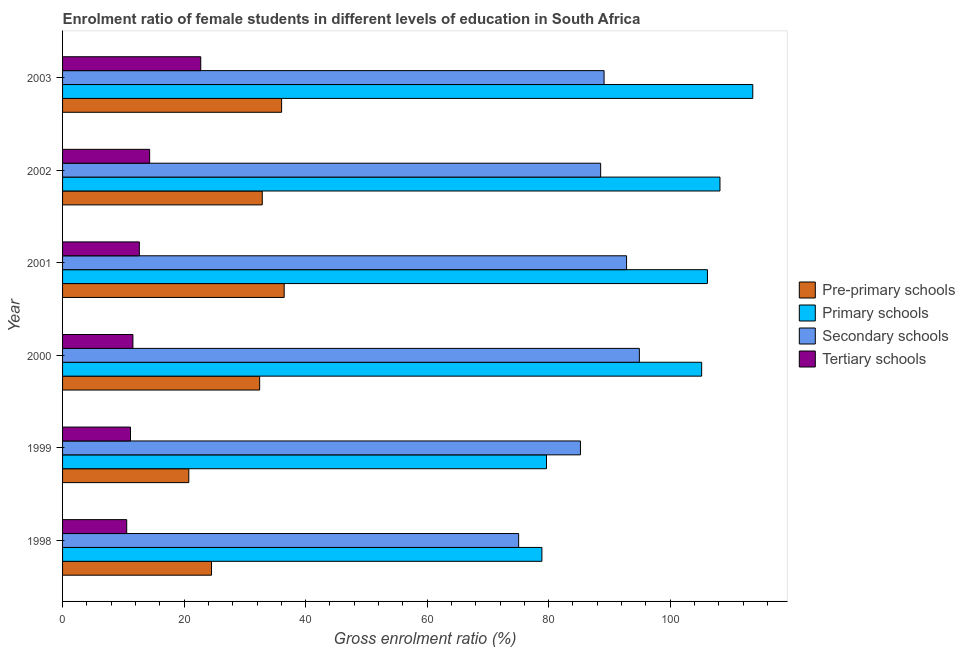How many groups of bars are there?
Your response must be concise. 6. Are the number of bars on each tick of the Y-axis equal?
Offer a very short reply. Yes. How many bars are there on the 5th tick from the top?
Keep it short and to the point. 4. What is the gross enrolment ratio(male) in tertiary schools in 2000?
Your answer should be very brief. 11.58. Across all years, what is the maximum gross enrolment ratio(male) in pre-primary schools?
Make the answer very short. 36.47. Across all years, what is the minimum gross enrolment ratio(male) in primary schools?
Offer a terse response. 78.89. In which year was the gross enrolment ratio(male) in tertiary schools maximum?
Ensure brevity in your answer.  2003. What is the total gross enrolment ratio(male) in secondary schools in the graph?
Your response must be concise. 525.71. What is the difference between the gross enrolment ratio(male) in secondary schools in 1998 and that in 2000?
Your response must be concise. -19.87. What is the difference between the gross enrolment ratio(male) in primary schools in 2000 and the gross enrolment ratio(male) in tertiary schools in 2001?
Your response must be concise. 92.54. What is the average gross enrolment ratio(male) in primary schools per year?
Provide a short and direct response. 98.6. In the year 2003, what is the difference between the gross enrolment ratio(male) in secondary schools and gross enrolment ratio(male) in tertiary schools?
Your response must be concise. 66.38. In how many years, is the gross enrolment ratio(male) in pre-primary schools greater than 4 %?
Provide a short and direct response. 6. Is the gross enrolment ratio(male) in pre-primary schools in 1998 less than that in 2000?
Provide a short and direct response. Yes. What is the difference between the highest and the second highest gross enrolment ratio(male) in tertiary schools?
Ensure brevity in your answer.  8.41. What is the difference between the highest and the lowest gross enrolment ratio(male) in tertiary schools?
Your response must be concise. 12.18. Is it the case that in every year, the sum of the gross enrolment ratio(male) in pre-primary schools and gross enrolment ratio(male) in secondary schools is greater than the sum of gross enrolment ratio(male) in tertiary schools and gross enrolment ratio(male) in primary schools?
Ensure brevity in your answer.  No. What does the 4th bar from the top in 2003 represents?
Your answer should be very brief. Pre-primary schools. What does the 1st bar from the bottom in 2002 represents?
Make the answer very short. Pre-primary schools. Is it the case that in every year, the sum of the gross enrolment ratio(male) in pre-primary schools and gross enrolment ratio(male) in primary schools is greater than the gross enrolment ratio(male) in secondary schools?
Keep it short and to the point. Yes. How many bars are there?
Ensure brevity in your answer.  24. Are all the bars in the graph horizontal?
Your response must be concise. Yes. How many years are there in the graph?
Offer a terse response. 6. What is the difference between two consecutive major ticks on the X-axis?
Keep it short and to the point. 20. Are the values on the major ticks of X-axis written in scientific E-notation?
Provide a short and direct response. No. How many legend labels are there?
Make the answer very short. 4. How are the legend labels stacked?
Offer a very short reply. Vertical. What is the title of the graph?
Offer a terse response. Enrolment ratio of female students in different levels of education in South Africa. Does "Macroeconomic management" appear as one of the legend labels in the graph?
Make the answer very short. No. What is the label or title of the X-axis?
Ensure brevity in your answer.  Gross enrolment ratio (%). What is the label or title of the Y-axis?
Make the answer very short. Year. What is the Gross enrolment ratio (%) in Pre-primary schools in 1998?
Ensure brevity in your answer.  24.51. What is the Gross enrolment ratio (%) of Primary schools in 1998?
Your answer should be very brief. 78.89. What is the Gross enrolment ratio (%) in Secondary schools in 1998?
Offer a very short reply. 75.06. What is the Gross enrolment ratio (%) in Tertiary schools in 1998?
Make the answer very short. 10.56. What is the Gross enrolment ratio (%) in Pre-primary schools in 1999?
Make the answer very short. 20.78. What is the Gross enrolment ratio (%) in Primary schools in 1999?
Ensure brevity in your answer.  79.64. What is the Gross enrolment ratio (%) of Secondary schools in 1999?
Your answer should be compact. 85.23. What is the Gross enrolment ratio (%) of Tertiary schools in 1999?
Your answer should be compact. 11.18. What is the Gross enrolment ratio (%) in Pre-primary schools in 2000?
Ensure brevity in your answer.  32.44. What is the Gross enrolment ratio (%) in Primary schools in 2000?
Your response must be concise. 105.18. What is the Gross enrolment ratio (%) in Secondary schools in 2000?
Your response must be concise. 94.93. What is the Gross enrolment ratio (%) in Tertiary schools in 2000?
Ensure brevity in your answer.  11.58. What is the Gross enrolment ratio (%) in Pre-primary schools in 2001?
Keep it short and to the point. 36.47. What is the Gross enrolment ratio (%) in Primary schools in 2001?
Your answer should be very brief. 106.13. What is the Gross enrolment ratio (%) in Secondary schools in 2001?
Ensure brevity in your answer.  92.82. What is the Gross enrolment ratio (%) of Tertiary schools in 2001?
Your answer should be very brief. 12.64. What is the Gross enrolment ratio (%) of Pre-primary schools in 2002?
Your response must be concise. 32.87. What is the Gross enrolment ratio (%) of Primary schools in 2002?
Provide a short and direct response. 108.19. What is the Gross enrolment ratio (%) in Secondary schools in 2002?
Your answer should be very brief. 88.56. What is the Gross enrolment ratio (%) of Tertiary schools in 2002?
Ensure brevity in your answer.  14.33. What is the Gross enrolment ratio (%) in Pre-primary schools in 2003?
Offer a terse response. 36.05. What is the Gross enrolment ratio (%) in Primary schools in 2003?
Offer a terse response. 113.59. What is the Gross enrolment ratio (%) of Secondary schools in 2003?
Provide a short and direct response. 89.12. What is the Gross enrolment ratio (%) in Tertiary schools in 2003?
Give a very brief answer. 22.74. Across all years, what is the maximum Gross enrolment ratio (%) of Pre-primary schools?
Provide a short and direct response. 36.47. Across all years, what is the maximum Gross enrolment ratio (%) of Primary schools?
Give a very brief answer. 113.59. Across all years, what is the maximum Gross enrolment ratio (%) in Secondary schools?
Your answer should be compact. 94.93. Across all years, what is the maximum Gross enrolment ratio (%) of Tertiary schools?
Provide a short and direct response. 22.74. Across all years, what is the minimum Gross enrolment ratio (%) in Pre-primary schools?
Provide a short and direct response. 20.78. Across all years, what is the minimum Gross enrolment ratio (%) of Primary schools?
Provide a succinct answer. 78.89. Across all years, what is the minimum Gross enrolment ratio (%) in Secondary schools?
Provide a short and direct response. 75.06. Across all years, what is the minimum Gross enrolment ratio (%) of Tertiary schools?
Keep it short and to the point. 10.56. What is the total Gross enrolment ratio (%) in Pre-primary schools in the graph?
Offer a terse response. 183.11. What is the total Gross enrolment ratio (%) of Primary schools in the graph?
Offer a very short reply. 591.62. What is the total Gross enrolment ratio (%) of Secondary schools in the graph?
Ensure brevity in your answer.  525.71. What is the total Gross enrolment ratio (%) of Tertiary schools in the graph?
Your answer should be very brief. 83.02. What is the difference between the Gross enrolment ratio (%) in Pre-primary schools in 1998 and that in 1999?
Keep it short and to the point. 3.74. What is the difference between the Gross enrolment ratio (%) of Primary schools in 1998 and that in 1999?
Provide a short and direct response. -0.76. What is the difference between the Gross enrolment ratio (%) in Secondary schools in 1998 and that in 1999?
Your answer should be compact. -10.17. What is the difference between the Gross enrolment ratio (%) of Tertiary schools in 1998 and that in 1999?
Provide a succinct answer. -0.62. What is the difference between the Gross enrolment ratio (%) of Pre-primary schools in 1998 and that in 2000?
Give a very brief answer. -7.92. What is the difference between the Gross enrolment ratio (%) of Primary schools in 1998 and that in 2000?
Make the answer very short. -26.29. What is the difference between the Gross enrolment ratio (%) in Secondary schools in 1998 and that in 2000?
Offer a terse response. -19.87. What is the difference between the Gross enrolment ratio (%) in Tertiary schools in 1998 and that in 2000?
Offer a very short reply. -1.02. What is the difference between the Gross enrolment ratio (%) of Pre-primary schools in 1998 and that in 2001?
Your answer should be very brief. -11.96. What is the difference between the Gross enrolment ratio (%) in Primary schools in 1998 and that in 2001?
Provide a short and direct response. -27.24. What is the difference between the Gross enrolment ratio (%) in Secondary schools in 1998 and that in 2001?
Provide a short and direct response. -17.76. What is the difference between the Gross enrolment ratio (%) in Tertiary schools in 1998 and that in 2001?
Give a very brief answer. -2.08. What is the difference between the Gross enrolment ratio (%) of Pre-primary schools in 1998 and that in 2002?
Your answer should be very brief. -8.35. What is the difference between the Gross enrolment ratio (%) in Primary schools in 1998 and that in 2002?
Ensure brevity in your answer.  -29.31. What is the difference between the Gross enrolment ratio (%) in Secondary schools in 1998 and that in 2002?
Give a very brief answer. -13.5. What is the difference between the Gross enrolment ratio (%) in Tertiary schools in 1998 and that in 2002?
Your response must be concise. -3.77. What is the difference between the Gross enrolment ratio (%) of Pre-primary schools in 1998 and that in 2003?
Offer a terse response. -11.53. What is the difference between the Gross enrolment ratio (%) of Primary schools in 1998 and that in 2003?
Your response must be concise. -34.7. What is the difference between the Gross enrolment ratio (%) in Secondary schools in 1998 and that in 2003?
Your answer should be very brief. -14.06. What is the difference between the Gross enrolment ratio (%) in Tertiary schools in 1998 and that in 2003?
Your response must be concise. -12.18. What is the difference between the Gross enrolment ratio (%) of Pre-primary schools in 1999 and that in 2000?
Your answer should be compact. -11.66. What is the difference between the Gross enrolment ratio (%) in Primary schools in 1999 and that in 2000?
Offer a very short reply. -25.53. What is the difference between the Gross enrolment ratio (%) of Secondary schools in 1999 and that in 2000?
Offer a very short reply. -9.69. What is the difference between the Gross enrolment ratio (%) of Tertiary schools in 1999 and that in 2000?
Your response must be concise. -0.4. What is the difference between the Gross enrolment ratio (%) in Pre-primary schools in 1999 and that in 2001?
Give a very brief answer. -15.7. What is the difference between the Gross enrolment ratio (%) of Primary schools in 1999 and that in 2001?
Provide a short and direct response. -26.49. What is the difference between the Gross enrolment ratio (%) of Secondary schools in 1999 and that in 2001?
Provide a succinct answer. -7.59. What is the difference between the Gross enrolment ratio (%) in Tertiary schools in 1999 and that in 2001?
Your answer should be compact. -1.46. What is the difference between the Gross enrolment ratio (%) in Pre-primary schools in 1999 and that in 2002?
Ensure brevity in your answer.  -12.09. What is the difference between the Gross enrolment ratio (%) of Primary schools in 1999 and that in 2002?
Offer a terse response. -28.55. What is the difference between the Gross enrolment ratio (%) in Secondary schools in 1999 and that in 2002?
Your response must be concise. -3.32. What is the difference between the Gross enrolment ratio (%) in Tertiary schools in 1999 and that in 2002?
Your response must be concise. -3.15. What is the difference between the Gross enrolment ratio (%) of Pre-primary schools in 1999 and that in 2003?
Your answer should be very brief. -15.27. What is the difference between the Gross enrolment ratio (%) of Primary schools in 1999 and that in 2003?
Your answer should be very brief. -33.95. What is the difference between the Gross enrolment ratio (%) in Secondary schools in 1999 and that in 2003?
Provide a short and direct response. -3.89. What is the difference between the Gross enrolment ratio (%) of Tertiary schools in 1999 and that in 2003?
Provide a succinct answer. -11.56. What is the difference between the Gross enrolment ratio (%) in Pre-primary schools in 2000 and that in 2001?
Ensure brevity in your answer.  -4.03. What is the difference between the Gross enrolment ratio (%) in Primary schools in 2000 and that in 2001?
Ensure brevity in your answer.  -0.95. What is the difference between the Gross enrolment ratio (%) in Secondary schools in 2000 and that in 2001?
Provide a short and direct response. 2.1. What is the difference between the Gross enrolment ratio (%) of Tertiary schools in 2000 and that in 2001?
Ensure brevity in your answer.  -1.06. What is the difference between the Gross enrolment ratio (%) in Pre-primary schools in 2000 and that in 2002?
Your response must be concise. -0.43. What is the difference between the Gross enrolment ratio (%) in Primary schools in 2000 and that in 2002?
Provide a succinct answer. -3.02. What is the difference between the Gross enrolment ratio (%) in Secondary schools in 2000 and that in 2002?
Offer a terse response. 6.37. What is the difference between the Gross enrolment ratio (%) of Tertiary schools in 2000 and that in 2002?
Your answer should be very brief. -2.75. What is the difference between the Gross enrolment ratio (%) in Pre-primary schools in 2000 and that in 2003?
Your response must be concise. -3.61. What is the difference between the Gross enrolment ratio (%) in Primary schools in 2000 and that in 2003?
Keep it short and to the point. -8.41. What is the difference between the Gross enrolment ratio (%) in Secondary schools in 2000 and that in 2003?
Provide a short and direct response. 5.81. What is the difference between the Gross enrolment ratio (%) in Tertiary schools in 2000 and that in 2003?
Keep it short and to the point. -11.16. What is the difference between the Gross enrolment ratio (%) of Pre-primary schools in 2001 and that in 2002?
Give a very brief answer. 3.61. What is the difference between the Gross enrolment ratio (%) of Primary schools in 2001 and that in 2002?
Provide a succinct answer. -2.06. What is the difference between the Gross enrolment ratio (%) of Secondary schools in 2001 and that in 2002?
Your answer should be compact. 4.27. What is the difference between the Gross enrolment ratio (%) of Tertiary schools in 2001 and that in 2002?
Give a very brief answer. -1.69. What is the difference between the Gross enrolment ratio (%) of Pre-primary schools in 2001 and that in 2003?
Offer a very short reply. 0.42. What is the difference between the Gross enrolment ratio (%) of Primary schools in 2001 and that in 2003?
Offer a very short reply. -7.46. What is the difference between the Gross enrolment ratio (%) of Secondary schools in 2001 and that in 2003?
Offer a terse response. 3.7. What is the difference between the Gross enrolment ratio (%) in Tertiary schools in 2001 and that in 2003?
Provide a short and direct response. -10.11. What is the difference between the Gross enrolment ratio (%) of Pre-primary schools in 2002 and that in 2003?
Ensure brevity in your answer.  -3.18. What is the difference between the Gross enrolment ratio (%) in Primary schools in 2002 and that in 2003?
Your response must be concise. -5.4. What is the difference between the Gross enrolment ratio (%) in Secondary schools in 2002 and that in 2003?
Ensure brevity in your answer.  -0.56. What is the difference between the Gross enrolment ratio (%) of Tertiary schools in 2002 and that in 2003?
Your answer should be very brief. -8.41. What is the difference between the Gross enrolment ratio (%) of Pre-primary schools in 1998 and the Gross enrolment ratio (%) of Primary schools in 1999?
Make the answer very short. -55.13. What is the difference between the Gross enrolment ratio (%) in Pre-primary schools in 1998 and the Gross enrolment ratio (%) in Secondary schools in 1999?
Ensure brevity in your answer.  -60.72. What is the difference between the Gross enrolment ratio (%) in Pre-primary schools in 1998 and the Gross enrolment ratio (%) in Tertiary schools in 1999?
Offer a very short reply. 13.33. What is the difference between the Gross enrolment ratio (%) of Primary schools in 1998 and the Gross enrolment ratio (%) of Secondary schools in 1999?
Provide a succinct answer. -6.34. What is the difference between the Gross enrolment ratio (%) in Primary schools in 1998 and the Gross enrolment ratio (%) in Tertiary schools in 1999?
Your answer should be compact. 67.71. What is the difference between the Gross enrolment ratio (%) of Secondary schools in 1998 and the Gross enrolment ratio (%) of Tertiary schools in 1999?
Offer a terse response. 63.88. What is the difference between the Gross enrolment ratio (%) in Pre-primary schools in 1998 and the Gross enrolment ratio (%) in Primary schools in 2000?
Ensure brevity in your answer.  -80.66. What is the difference between the Gross enrolment ratio (%) of Pre-primary schools in 1998 and the Gross enrolment ratio (%) of Secondary schools in 2000?
Your answer should be very brief. -70.41. What is the difference between the Gross enrolment ratio (%) of Pre-primary schools in 1998 and the Gross enrolment ratio (%) of Tertiary schools in 2000?
Provide a succinct answer. 12.94. What is the difference between the Gross enrolment ratio (%) in Primary schools in 1998 and the Gross enrolment ratio (%) in Secondary schools in 2000?
Keep it short and to the point. -16.04. What is the difference between the Gross enrolment ratio (%) in Primary schools in 1998 and the Gross enrolment ratio (%) in Tertiary schools in 2000?
Offer a very short reply. 67.31. What is the difference between the Gross enrolment ratio (%) of Secondary schools in 1998 and the Gross enrolment ratio (%) of Tertiary schools in 2000?
Your answer should be very brief. 63.48. What is the difference between the Gross enrolment ratio (%) of Pre-primary schools in 1998 and the Gross enrolment ratio (%) of Primary schools in 2001?
Provide a short and direct response. -81.62. What is the difference between the Gross enrolment ratio (%) of Pre-primary schools in 1998 and the Gross enrolment ratio (%) of Secondary schools in 2001?
Provide a short and direct response. -68.31. What is the difference between the Gross enrolment ratio (%) in Pre-primary schools in 1998 and the Gross enrolment ratio (%) in Tertiary schools in 2001?
Your response must be concise. 11.88. What is the difference between the Gross enrolment ratio (%) of Primary schools in 1998 and the Gross enrolment ratio (%) of Secondary schools in 2001?
Your answer should be compact. -13.93. What is the difference between the Gross enrolment ratio (%) in Primary schools in 1998 and the Gross enrolment ratio (%) in Tertiary schools in 2001?
Keep it short and to the point. 66.25. What is the difference between the Gross enrolment ratio (%) of Secondary schools in 1998 and the Gross enrolment ratio (%) of Tertiary schools in 2001?
Your response must be concise. 62.42. What is the difference between the Gross enrolment ratio (%) in Pre-primary schools in 1998 and the Gross enrolment ratio (%) in Primary schools in 2002?
Make the answer very short. -83.68. What is the difference between the Gross enrolment ratio (%) in Pre-primary schools in 1998 and the Gross enrolment ratio (%) in Secondary schools in 2002?
Make the answer very short. -64.04. What is the difference between the Gross enrolment ratio (%) in Pre-primary schools in 1998 and the Gross enrolment ratio (%) in Tertiary schools in 2002?
Ensure brevity in your answer.  10.18. What is the difference between the Gross enrolment ratio (%) of Primary schools in 1998 and the Gross enrolment ratio (%) of Secondary schools in 2002?
Your answer should be compact. -9.67. What is the difference between the Gross enrolment ratio (%) in Primary schools in 1998 and the Gross enrolment ratio (%) in Tertiary schools in 2002?
Make the answer very short. 64.56. What is the difference between the Gross enrolment ratio (%) in Secondary schools in 1998 and the Gross enrolment ratio (%) in Tertiary schools in 2002?
Provide a short and direct response. 60.73. What is the difference between the Gross enrolment ratio (%) of Pre-primary schools in 1998 and the Gross enrolment ratio (%) of Primary schools in 2003?
Keep it short and to the point. -89.08. What is the difference between the Gross enrolment ratio (%) in Pre-primary schools in 1998 and the Gross enrolment ratio (%) in Secondary schools in 2003?
Ensure brevity in your answer.  -64.61. What is the difference between the Gross enrolment ratio (%) in Pre-primary schools in 1998 and the Gross enrolment ratio (%) in Tertiary schools in 2003?
Give a very brief answer. 1.77. What is the difference between the Gross enrolment ratio (%) of Primary schools in 1998 and the Gross enrolment ratio (%) of Secondary schools in 2003?
Ensure brevity in your answer.  -10.23. What is the difference between the Gross enrolment ratio (%) in Primary schools in 1998 and the Gross enrolment ratio (%) in Tertiary schools in 2003?
Provide a short and direct response. 56.15. What is the difference between the Gross enrolment ratio (%) of Secondary schools in 1998 and the Gross enrolment ratio (%) of Tertiary schools in 2003?
Provide a short and direct response. 52.31. What is the difference between the Gross enrolment ratio (%) of Pre-primary schools in 1999 and the Gross enrolment ratio (%) of Primary schools in 2000?
Offer a very short reply. -84.4. What is the difference between the Gross enrolment ratio (%) in Pre-primary schools in 1999 and the Gross enrolment ratio (%) in Secondary schools in 2000?
Provide a short and direct response. -74.15. What is the difference between the Gross enrolment ratio (%) in Pre-primary schools in 1999 and the Gross enrolment ratio (%) in Tertiary schools in 2000?
Provide a succinct answer. 9.2. What is the difference between the Gross enrolment ratio (%) in Primary schools in 1999 and the Gross enrolment ratio (%) in Secondary schools in 2000?
Make the answer very short. -15.28. What is the difference between the Gross enrolment ratio (%) in Primary schools in 1999 and the Gross enrolment ratio (%) in Tertiary schools in 2000?
Your answer should be very brief. 68.07. What is the difference between the Gross enrolment ratio (%) in Secondary schools in 1999 and the Gross enrolment ratio (%) in Tertiary schools in 2000?
Offer a terse response. 73.65. What is the difference between the Gross enrolment ratio (%) of Pre-primary schools in 1999 and the Gross enrolment ratio (%) of Primary schools in 2001?
Ensure brevity in your answer.  -85.35. What is the difference between the Gross enrolment ratio (%) in Pre-primary schools in 1999 and the Gross enrolment ratio (%) in Secondary schools in 2001?
Provide a short and direct response. -72.05. What is the difference between the Gross enrolment ratio (%) in Pre-primary schools in 1999 and the Gross enrolment ratio (%) in Tertiary schools in 2001?
Your answer should be compact. 8.14. What is the difference between the Gross enrolment ratio (%) of Primary schools in 1999 and the Gross enrolment ratio (%) of Secondary schools in 2001?
Your response must be concise. -13.18. What is the difference between the Gross enrolment ratio (%) of Primary schools in 1999 and the Gross enrolment ratio (%) of Tertiary schools in 2001?
Keep it short and to the point. 67.01. What is the difference between the Gross enrolment ratio (%) of Secondary schools in 1999 and the Gross enrolment ratio (%) of Tertiary schools in 2001?
Ensure brevity in your answer.  72.6. What is the difference between the Gross enrolment ratio (%) of Pre-primary schools in 1999 and the Gross enrolment ratio (%) of Primary schools in 2002?
Keep it short and to the point. -87.42. What is the difference between the Gross enrolment ratio (%) of Pre-primary schools in 1999 and the Gross enrolment ratio (%) of Secondary schools in 2002?
Your response must be concise. -67.78. What is the difference between the Gross enrolment ratio (%) of Pre-primary schools in 1999 and the Gross enrolment ratio (%) of Tertiary schools in 2002?
Your answer should be very brief. 6.45. What is the difference between the Gross enrolment ratio (%) of Primary schools in 1999 and the Gross enrolment ratio (%) of Secondary schools in 2002?
Give a very brief answer. -8.91. What is the difference between the Gross enrolment ratio (%) of Primary schools in 1999 and the Gross enrolment ratio (%) of Tertiary schools in 2002?
Offer a very short reply. 65.31. What is the difference between the Gross enrolment ratio (%) in Secondary schools in 1999 and the Gross enrolment ratio (%) in Tertiary schools in 2002?
Make the answer very short. 70.9. What is the difference between the Gross enrolment ratio (%) in Pre-primary schools in 1999 and the Gross enrolment ratio (%) in Primary schools in 2003?
Keep it short and to the point. -92.82. What is the difference between the Gross enrolment ratio (%) in Pre-primary schools in 1999 and the Gross enrolment ratio (%) in Secondary schools in 2003?
Give a very brief answer. -68.34. What is the difference between the Gross enrolment ratio (%) in Pre-primary schools in 1999 and the Gross enrolment ratio (%) in Tertiary schools in 2003?
Offer a very short reply. -1.97. What is the difference between the Gross enrolment ratio (%) of Primary schools in 1999 and the Gross enrolment ratio (%) of Secondary schools in 2003?
Give a very brief answer. -9.48. What is the difference between the Gross enrolment ratio (%) of Primary schools in 1999 and the Gross enrolment ratio (%) of Tertiary schools in 2003?
Provide a short and direct response. 56.9. What is the difference between the Gross enrolment ratio (%) in Secondary schools in 1999 and the Gross enrolment ratio (%) in Tertiary schools in 2003?
Your answer should be very brief. 62.49. What is the difference between the Gross enrolment ratio (%) of Pre-primary schools in 2000 and the Gross enrolment ratio (%) of Primary schools in 2001?
Offer a terse response. -73.69. What is the difference between the Gross enrolment ratio (%) of Pre-primary schools in 2000 and the Gross enrolment ratio (%) of Secondary schools in 2001?
Offer a very short reply. -60.38. What is the difference between the Gross enrolment ratio (%) in Pre-primary schools in 2000 and the Gross enrolment ratio (%) in Tertiary schools in 2001?
Ensure brevity in your answer.  19.8. What is the difference between the Gross enrolment ratio (%) in Primary schools in 2000 and the Gross enrolment ratio (%) in Secondary schools in 2001?
Provide a short and direct response. 12.36. What is the difference between the Gross enrolment ratio (%) in Primary schools in 2000 and the Gross enrolment ratio (%) in Tertiary schools in 2001?
Offer a very short reply. 92.54. What is the difference between the Gross enrolment ratio (%) in Secondary schools in 2000 and the Gross enrolment ratio (%) in Tertiary schools in 2001?
Give a very brief answer. 82.29. What is the difference between the Gross enrolment ratio (%) of Pre-primary schools in 2000 and the Gross enrolment ratio (%) of Primary schools in 2002?
Offer a very short reply. -75.76. What is the difference between the Gross enrolment ratio (%) in Pre-primary schools in 2000 and the Gross enrolment ratio (%) in Secondary schools in 2002?
Your answer should be compact. -56.12. What is the difference between the Gross enrolment ratio (%) in Pre-primary schools in 2000 and the Gross enrolment ratio (%) in Tertiary schools in 2002?
Provide a succinct answer. 18.11. What is the difference between the Gross enrolment ratio (%) of Primary schools in 2000 and the Gross enrolment ratio (%) of Secondary schools in 2002?
Keep it short and to the point. 16.62. What is the difference between the Gross enrolment ratio (%) of Primary schools in 2000 and the Gross enrolment ratio (%) of Tertiary schools in 2002?
Offer a very short reply. 90.85. What is the difference between the Gross enrolment ratio (%) of Secondary schools in 2000 and the Gross enrolment ratio (%) of Tertiary schools in 2002?
Provide a short and direct response. 80.6. What is the difference between the Gross enrolment ratio (%) of Pre-primary schools in 2000 and the Gross enrolment ratio (%) of Primary schools in 2003?
Ensure brevity in your answer.  -81.15. What is the difference between the Gross enrolment ratio (%) of Pre-primary schools in 2000 and the Gross enrolment ratio (%) of Secondary schools in 2003?
Give a very brief answer. -56.68. What is the difference between the Gross enrolment ratio (%) of Pre-primary schools in 2000 and the Gross enrolment ratio (%) of Tertiary schools in 2003?
Offer a very short reply. 9.69. What is the difference between the Gross enrolment ratio (%) of Primary schools in 2000 and the Gross enrolment ratio (%) of Secondary schools in 2003?
Your response must be concise. 16.06. What is the difference between the Gross enrolment ratio (%) in Primary schools in 2000 and the Gross enrolment ratio (%) in Tertiary schools in 2003?
Your answer should be compact. 82.44. What is the difference between the Gross enrolment ratio (%) in Secondary schools in 2000 and the Gross enrolment ratio (%) in Tertiary schools in 2003?
Your response must be concise. 72.18. What is the difference between the Gross enrolment ratio (%) in Pre-primary schools in 2001 and the Gross enrolment ratio (%) in Primary schools in 2002?
Offer a terse response. -71.72. What is the difference between the Gross enrolment ratio (%) of Pre-primary schools in 2001 and the Gross enrolment ratio (%) of Secondary schools in 2002?
Ensure brevity in your answer.  -52.08. What is the difference between the Gross enrolment ratio (%) of Pre-primary schools in 2001 and the Gross enrolment ratio (%) of Tertiary schools in 2002?
Give a very brief answer. 22.14. What is the difference between the Gross enrolment ratio (%) in Primary schools in 2001 and the Gross enrolment ratio (%) in Secondary schools in 2002?
Provide a short and direct response. 17.57. What is the difference between the Gross enrolment ratio (%) in Primary schools in 2001 and the Gross enrolment ratio (%) in Tertiary schools in 2002?
Your response must be concise. 91.8. What is the difference between the Gross enrolment ratio (%) of Secondary schools in 2001 and the Gross enrolment ratio (%) of Tertiary schools in 2002?
Your response must be concise. 78.49. What is the difference between the Gross enrolment ratio (%) of Pre-primary schools in 2001 and the Gross enrolment ratio (%) of Primary schools in 2003?
Provide a short and direct response. -77.12. What is the difference between the Gross enrolment ratio (%) of Pre-primary schools in 2001 and the Gross enrolment ratio (%) of Secondary schools in 2003?
Provide a short and direct response. -52.65. What is the difference between the Gross enrolment ratio (%) in Pre-primary schools in 2001 and the Gross enrolment ratio (%) in Tertiary schools in 2003?
Your answer should be compact. 13.73. What is the difference between the Gross enrolment ratio (%) in Primary schools in 2001 and the Gross enrolment ratio (%) in Secondary schools in 2003?
Your answer should be very brief. 17.01. What is the difference between the Gross enrolment ratio (%) in Primary schools in 2001 and the Gross enrolment ratio (%) in Tertiary schools in 2003?
Your answer should be compact. 83.39. What is the difference between the Gross enrolment ratio (%) of Secondary schools in 2001 and the Gross enrolment ratio (%) of Tertiary schools in 2003?
Give a very brief answer. 70.08. What is the difference between the Gross enrolment ratio (%) of Pre-primary schools in 2002 and the Gross enrolment ratio (%) of Primary schools in 2003?
Ensure brevity in your answer.  -80.73. What is the difference between the Gross enrolment ratio (%) of Pre-primary schools in 2002 and the Gross enrolment ratio (%) of Secondary schools in 2003?
Your answer should be compact. -56.25. What is the difference between the Gross enrolment ratio (%) of Pre-primary schools in 2002 and the Gross enrolment ratio (%) of Tertiary schools in 2003?
Keep it short and to the point. 10.12. What is the difference between the Gross enrolment ratio (%) in Primary schools in 2002 and the Gross enrolment ratio (%) in Secondary schools in 2003?
Your answer should be very brief. 19.07. What is the difference between the Gross enrolment ratio (%) in Primary schools in 2002 and the Gross enrolment ratio (%) in Tertiary schools in 2003?
Provide a short and direct response. 85.45. What is the difference between the Gross enrolment ratio (%) in Secondary schools in 2002 and the Gross enrolment ratio (%) in Tertiary schools in 2003?
Give a very brief answer. 65.81. What is the average Gross enrolment ratio (%) in Pre-primary schools per year?
Provide a succinct answer. 30.52. What is the average Gross enrolment ratio (%) in Primary schools per year?
Your response must be concise. 98.6. What is the average Gross enrolment ratio (%) of Secondary schools per year?
Offer a terse response. 87.62. What is the average Gross enrolment ratio (%) in Tertiary schools per year?
Offer a very short reply. 13.84. In the year 1998, what is the difference between the Gross enrolment ratio (%) of Pre-primary schools and Gross enrolment ratio (%) of Primary schools?
Provide a succinct answer. -54.37. In the year 1998, what is the difference between the Gross enrolment ratio (%) in Pre-primary schools and Gross enrolment ratio (%) in Secondary schools?
Make the answer very short. -50.54. In the year 1998, what is the difference between the Gross enrolment ratio (%) in Pre-primary schools and Gross enrolment ratio (%) in Tertiary schools?
Give a very brief answer. 13.96. In the year 1998, what is the difference between the Gross enrolment ratio (%) in Primary schools and Gross enrolment ratio (%) in Secondary schools?
Provide a succinct answer. 3.83. In the year 1998, what is the difference between the Gross enrolment ratio (%) of Primary schools and Gross enrolment ratio (%) of Tertiary schools?
Your answer should be compact. 68.33. In the year 1998, what is the difference between the Gross enrolment ratio (%) in Secondary schools and Gross enrolment ratio (%) in Tertiary schools?
Give a very brief answer. 64.5. In the year 1999, what is the difference between the Gross enrolment ratio (%) in Pre-primary schools and Gross enrolment ratio (%) in Primary schools?
Your answer should be compact. -58.87. In the year 1999, what is the difference between the Gross enrolment ratio (%) in Pre-primary schools and Gross enrolment ratio (%) in Secondary schools?
Your response must be concise. -64.46. In the year 1999, what is the difference between the Gross enrolment ratio (%) of Pre-primary schools and Gross enrolment ratio (%) of Tertiary schools?
Give a very brief answer. 9.6. In the year 1999, what is the difference between the Gross enrolment ratio (%) in Primary schools and Gross enrolment ratio (%) in Secondary schools?
Your response must be concise. -5.59. In the year 1999, what is the difference between the Gross enrolment ratio (%) in Primary schools and Gross enrolment ratio (%) in Tertiary schools?
Keep it short and to the point. 68.46. In the year 1999, what is the difference between the Gross enrolment ratio (%) in Secondary schools and Gross enrolment ratio (%) in Tertiary schools?
Provide a short and direct response. 74.05. In the year 2000, what is the difference between the Gross enrolment ratio (%) in Pre-primary schools and Gross enrolment ratio (%) in Primary schools?
Your answer should be compact. -72.74. In the year 2000, what is the difference between the Gross enrolment ratio (%) of Pre-primary schools and Gross enrolment ratio (%) of Secondary schools?
Keep it short and to the point. -62.49. In the year 2000, what is the difference between the Gross enrolment ratio (%) of Pre-primary schools and Gross enrolment ratio (%) of Tertiary schools?
Make the answer very short. 20.86. In the year 2000, what is the difference between the Gross enrolment ratio (%) in Primary schools and Gross enrolment ratio (%) in Secondary schools?
Make the answer very short. 10.25. In the year 2000, what is the difference between the Gross enrolment ratio (%) of Primary schools and Gross enrolment ratio (%) of Tertiary schools?
Provide a succinct answer. 93.6. In the year 2000, what is the difference between the Gross enrolment ratio (%) in Secondary schools and Gross enrolment ratio (%) in Tertiary schools?
Offer a terse response. 83.35. In the year 2001, what is the difference between the Gross enrolment ratio (%) in Pre-primary schools and Gross enrolment ratio (%) in Primary schools?
Your answer should be very brief. -69.66. In the year 2001, what is the difference between the Gross enrolment ratio (%) of Pre-primary schools and Gross enrolment ratio (%) of Secondary schools?
Keep it short and to the point. -56.35. In the year 2001, what is the difference between the Gross enrolment ratio (%) in Pre-primary schools and Gross enrolment ratio (%) in Tertiary schools?
Provide a short and direct response. 23.84. In the year 2001, what is the difference between the Gross enrolment ratio (%) of Primary schools and Gross enrolment ratio (%) of Secondary schools?
Keep it short and to the point. 13.31. In the year 2001, what is the difference between the Gross enrolment ratio (%) of Primary schools and Gross enrolment ratio (%) of Tertiary schools?
Make the answer very short. 93.49. In the year 2001, what is the difference between the Gross enrolment ratio (%) of Secondary schools and Gross enrolment ratio (%) of Tertiary schools?
Your answer should be very brief. 80.19. In the year 2002, what is the difference between the Gross enrolment ratio (%) in Pre-primary schools and Gross enrolment ratio (%) in Primary schools?
Your response must be concise. -75.33. In the year 2002, what is the difference between the Gross enrolment ratio (%) in Pre-primary schools and Gross enrolment ratio (%) in Secondary schools?
Your answer should be compact. -55.69. In the year 2002, what is the difference between the Gross enrolment ratio (%) in Pre-primary schools and Gross enrolment ratio (%) in Tertiary schools?
Provide a short and direct response. 18.54. In the year 2002, what is the difference between the Gross enrolment ratio (%) of Primary schools and Gross enrolment ratio (%) of Secondary schools?
Provide a short and direct response. 19.64. In the year 2002, what is the difference between the Gross enrolment ratio (%) in Primary schools and Gross enrolment ratio (%) in Tertiary schools?
Offer a terse response. 93.86. In the year 2002, what is the difference between the Gross enrolment ratio (%) of Secondary schools and Gross enrolment ratio (%) of Tertiary schools?
Keep it short and to the point. 74.23. In the year 2003, what is the difference between the Gross enrolment ratio (%) of Pre-primary schools and Gross enrolment ratio (%) of Primary schools?
Give a very brief answer. -77.54. In the year 2003, what is the difference between the Gross enrolment ratio (%) of Pre-primary schools and Gross enrolment ratio (%) of Secondary schools?
Provide a succinct answer. -53.07. In the year 2003, what is the difference between the Gross enrolment ratio (%) of Pre-primary schools and Gross enrolment ratio (%) of Tertiary schools?
Offer a very short reply. 13.31. In the year 2003, what is the difference between the Gross enrolment ratio (%) in Primary schools and Gross enrolment ratio (%) in Secondary schools?
Provide a succinct answer. 24.47. In the year 2003, what is the difference between the Gross enrolment ratio (%) of Primary schools and Gross enrolment ratio (%) of Tertiary schools?
Provide a short and direct response. 90.85. In the year 2003, what is the difference between the Gross enrolment ratio (%) of Secondary schools and Gross enrolment ratio (%) of Tertiary schools?
Give a very brief answer. 66.38. What is the ratio of the Gross enrolment ratio (%) of Pre-primary schools in 1998 to that in 1999?
Offer a very short reply. 1.18. What is the ratio of the Gross enrolment ratio (%) of Primary schools in 1998 to that in 1999?
Your answer should be very brief. 0.99. What is the ratio of the Gross enrolment ratio (%) of Secondary schools in 1998 to that in 1999?
Provide a succinct answer. 0.88. What is the ratio of the Gross enrolment ratio (%) in Tertiary schools in 1998 to that in 1999?
Provide a succinct answer. 0.94. What is the ratio of the Gross enrolment ratio (%) in Pre-primary schools in 1998 to that in 2000?
Provide a short and direct response. 0.76. What is the ratio of the Gross enrolment ratio (%) in Secondary schools in 1998 to that in 2000?
Your response must be concise. 0.79. What is the ratio of the Gross enrolment ratio (%) of Tertiary schools in 1998 to that in 2000?
Your response must be concise. 0.91. What is the ratio of the Gross enrolment ratio (%) of Pre-primary schools in 1998 to that in 2001?
Make the answer very short. 0.67. What is the ratio of the Gross enrolment ratio (%) in Primary schools in 1998 to that in 2001?
Provide a succinct answer. 0.74. What is the ratio of the Gross enrolment ratio (%) of Secondary schools in 1998 to that in 2001?
Keep it short and to the point. 0.81. What is the ratio of the Gross enrolment ratio (%) in Tertiary schools in 1998 to that in 2001?
Ensure brevity in your answer.  0.84. What is the ratio of the Gross enrolment ratio (%) of Pre-primary schools in 1998 to that in 2002?
Your answer should be compact. 0.75. What is the ratio of the Gross enrolment ratio (%) of Primary schools in 1998 to that in 2002?
Your answer should be compact. 0.73. What is the ratio of the Gross enrolment ratio (%) of Secondary schools in 1998 to that in 2002?
Keep it short and to the point. 0.85. What is the ratio of the Gross enrolment ratio (%) of Tertiary schools in 1998 to that in 2002?
Make the answer very short. 0.74. What is the ratio of the Gross enrolment ratio (%) of Pre-primary schools in 1998 to that in 2003?
Keep it short and to the point. 0.68. What is the ratio of the Gross enrolment ratio (%) in Primary schools in 1998 to that in 2003?
Your answer should be compact. 0.69. What is the ratio of the Gross enrolment ratio (%) of Secondary schools in 1998 to that in 2003?
Provide a short and direct response. 0.84. What is the ratio of the Gross enrolment ratio (%) in Tertiary schools in 1998 to that in 2003?
Provide a succinct answer. 0.46. What is the ratio of the Gross enrolment ratio (%) of Pre-primary schools in 1999 to that in 2000?
Provide a short and direct response. 0.64. What is the ratio of the Gross enrolment ratio (%) in Primary schools in 1999 to that in 2000?
Make the answer very short. 0.76. What is the ratio of the Gross enrolment ratio (%) in Secondary schools in 1999 to that in 2000?
Give a very brief answer. 0.9. What is the ratio of the Gross enrolment ratio (%) in Tertiary schools in 1999 to that in 2000?
Provide a succinct answer. 0.97. What is the ratio of the Gross enrolment ratio (%) of Pre-primary schools in 1999 to that in 2001?
Offer a very short reply. 0.57. What is the ratio of the Gross enrolment ratio (%) of Primary schools in 1999 to that in 2001?
Give a very brief answer. 0.75. What is the ratio of the Gross enrolment ratio (%) of Secondary schools in 1999 to that in 2001?
Keep it short and to the point. 0.92. What is the ratio of the Gross enrolment ratio (%) in Tertiary schools in 1999 to that in 2001?
Your response must be concise. 0.88. What is the ratio of the Gross enrolment ratio (%) in Pre-primary schools in 1999 to that in 2002?
Your response must be concise. 0.63. What is the ratio of the Gross enrolment ratio (%) in Primary schools in 1999 to that in 2002?
Give a very brief answer. 0.74. What is the ratio of the Gross enrolment ratio (%) in Secondary schools in 1999 to that in 2002?
Your response must be concise. 0.96. What is the ratio of the Gross enrolment ratio (%) of Tertiary schools in 1999 to that in 2002?
Make the answer very short. 0.78. What is the ratio of the Gross enrolment ratio (%) in Pre-primary schools in 1999 to that in 2003?
Make the answer very short. 0.58. What is the ratio of the Gross enrolment ratio (%) in Primary schools in 1999 to that in 2003?
Your response must be concise. 0.7. What is the ratio of the Gross enrolment ratio (%) in Secondary schools in 1999 to that in 2003?
Provide a succinct answer. 0.96. What is the ratio of the Gross enrolment ratio (%) of Tertiary schools in 1999 to that in 2003?
Make the answer very short. 0.49. What is the ratio of the Gross enrolment ratio (%) in Pre-primary schools in 2000 to that in 2001?
Provide a succinct answer. 0.89. What is the ratio of the Gross enrolment ratio (%) in Secondary schools in 2000 to that in 2001?
Your response must be concise. 1.02. What is the ratio of the Gross enrolment ratio (%) of Tertiary schools in 2000 to that in 2001?
Give a very brief answer. 0.92. What is the ratio of the Gross enrolment ratio (%) of Primary schools in 2000 to that in 2002?
Keep it short and to the point. 0.97. What is the ratio of the Gross enrolment ratio (%) of Secondary schools in 2000 to that in 2002?
Ensure brevity in your answer.  1.07. What is the ratio of the Gross enrolment ratio (%) in Tertiary schools in 2000 to that in 2002?
Ensure brevity in your answer.  0.81. What is the ratio of the Gross enrolment ratio (%) of Pre-primary schools in 2000 to that in 2003?
Offer a very short reply. 0.9. What is the ratio of the Gross enrolment ratio (%) of Primary schools in 2000 to that in 2003?
Your response must be concise. 0.93. What is the ratio of the Gross enrolment ratio (%) in Secondary schools in 2000 to that in 2003?
Ensure brevity in your answer.  1.07. What is the ratio of the Gross enrolment ratio (%) in Tertiary schools in 2000 to that in 2003?
Offer a terse response. 0.51. What is the ratio of the Gross enrolment ratio (%) of Pre-primary schools in 2001 to that in 2002?
Your answer should be compact. 1.11. What is the ratio of the Gross enrolment ratio (%) in Primary schools in 2001 to that in 2002?
Offer a very short reply. 0.98. What is the ratio of the Gross enrolment ratio (%) in Secondary schools in 2001 to that in 2002?
Offer a terse response. 1.05. What is the ratio of the Gross enrolment ratio (%) of Tertiary schools in 2001 to that in 2002?
Your answer should be very brief. 0.88. What is the ratio of the Gross enrolment ratio (%) in Pre-primary schools in 2001 to that in 2003?
Your answer should be very brief. 1.01. What is the ratio of the Gross enrolment ratio (%) in Primary schools in 2001 to that in 2003?
Offer a very short reply. 0.93. What is the ratio of the Gross enrolment ratio (%) of Secondary schools in 2001 to that in 2003?
Ensure brevity in your answer.  1.04. What is the ratio of the Gross enrolment ratio (%) in Tertiary schools in 2001 to that in 2003?
Provide a short and direct response. 0.56. What is the ratio of the Gross enrolment ratio (%) in Pre-primary schools in 2002 to that in 2003?
Your answer should be compact. 0.91. What is the ratio of the Gross enrolment ratio (%) of Primary schools in 2002 to that in 2003?
Keep it short and to the point. 0.95. What is the ratio of the Gross enrolment ratio (%) in Secondary schools in 2002 to that in 2003?
Your answer should be compact. 0.99. What is the ratio of the Gross enrolment ratio (%) of Tertiary schools in 2002 to that in 2003?
Offer a terse response. 0.63. What is the difference between the highest and the second highest Gross enrolment ratio (%) in Pre-primary schools?
Make the answer very short. 0.42. What is the difference between the highest and the second highest Gross enrolment ratio (%) of Primary schools?
Your answer should be compact. 5.4. What is the difference between the highest and the second highest Gross enrolment ratio (%) of Secondary schools?
Give a very brief answer. 2.1. What is the difference between the highest and the second highest Gross enrolment ratio (%) in Tertiary schools?
Provide a short and direct response. 8.41. What is the difference between the highest and the lowest Gross enrolment ratio (%) in Pre-primary schools?
Your answer should be very brief. 15.7. What is the difference between the highest and the lowest Gross enrolment ratio (%) of Primary schools?
Offer a very short reply. 34.7. What is the difference between the highest and the lowest Gross enrolment ratio (%) in Secondary schools?
Ensure brevity in your answer.  19.87. What is the difference between the highest and the lowest Gross enrolment ratio (%) in Tertiary schools?
Offer a terse response. 12.18. 